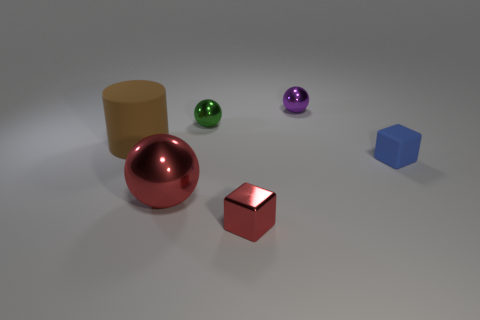Is the big red shiny thing the same shape as the small green thing?
Offer a terse response. Yes. Is there any other thing that is the same shape as the tiny red metallic thing?
Make the answer very short. Yes. Is the red object that is behind the red block made of the same material as the purple sphere?
Make the answer very short. Yes. What shape is the tiny thing that is both to the left of the small purple object and in front of the big cylinder?
Ensure brevity in your answer.  Cube. There is a big thing that is in front of the large brown rubber cylinder; are there any small cubes behind it?
Offer a very short reply. Yes. How many other objects are the same material as the big red ball?
Your answer should be compact. 3. There is a large thing that is in front of the big brown thing; does it have the same shape as the matte thing that is in front of the matte cylinder?
Make the answer very short. No. Does the brown cylinder have the same material as the blue cube?
Keep it short and to the point. Yes. There is a cube on the left side of the purple thing on the right side of the small block that is left of the purple metallic ball; what size is it?
Give a very brief answer. Small. How many other objects are there of the same color as the large metal thing?
Keep it short and to the point. 1. 